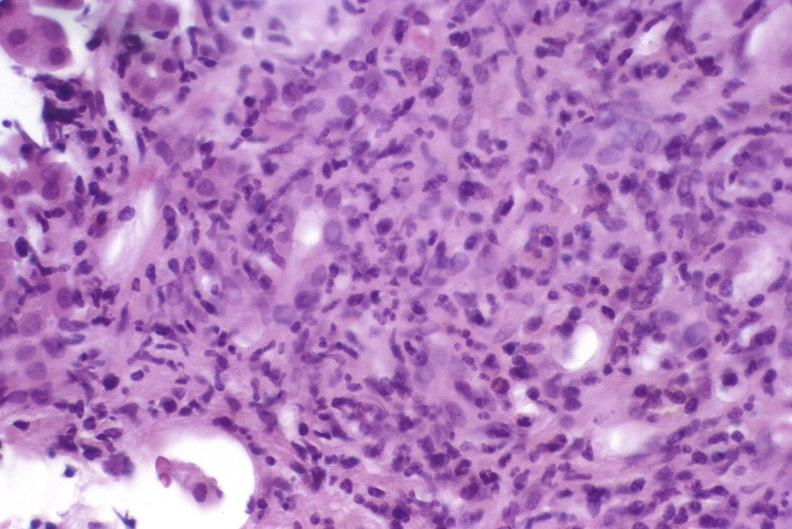s hepatobiliary present?
Answer the question using a single word or phrase. Yes 